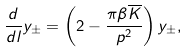Convert formula to latex. <formula><loc_0><loc_0><loc_500><loc_500>\frac { d } { d l } y _ { \pm } = \left ( 2 - \frac { \pi \beta { \overline { K } } } { p ^ { 2 } } \right ) y _ { \pm } ,</formula> 